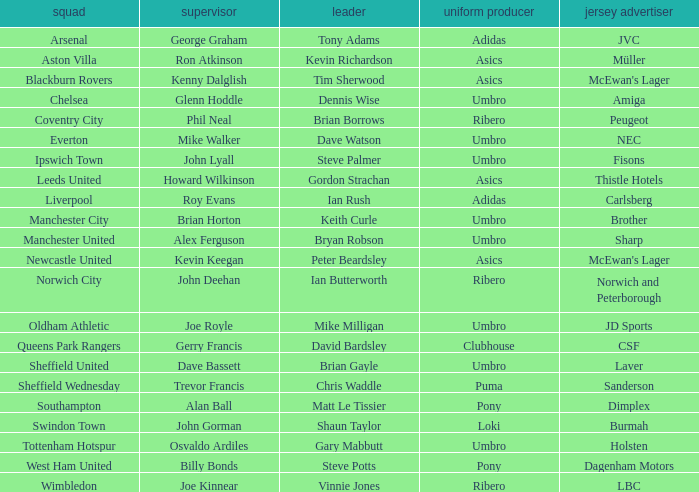Which manager has Manchester City as the team? Brian Horton. 